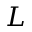<formula> <loc_0><loc_0><loc_500><loc_500>L</formula> 